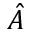<formula> <loc_0><loc_0><loc_500><loc_500>\hat { A }</formula> 